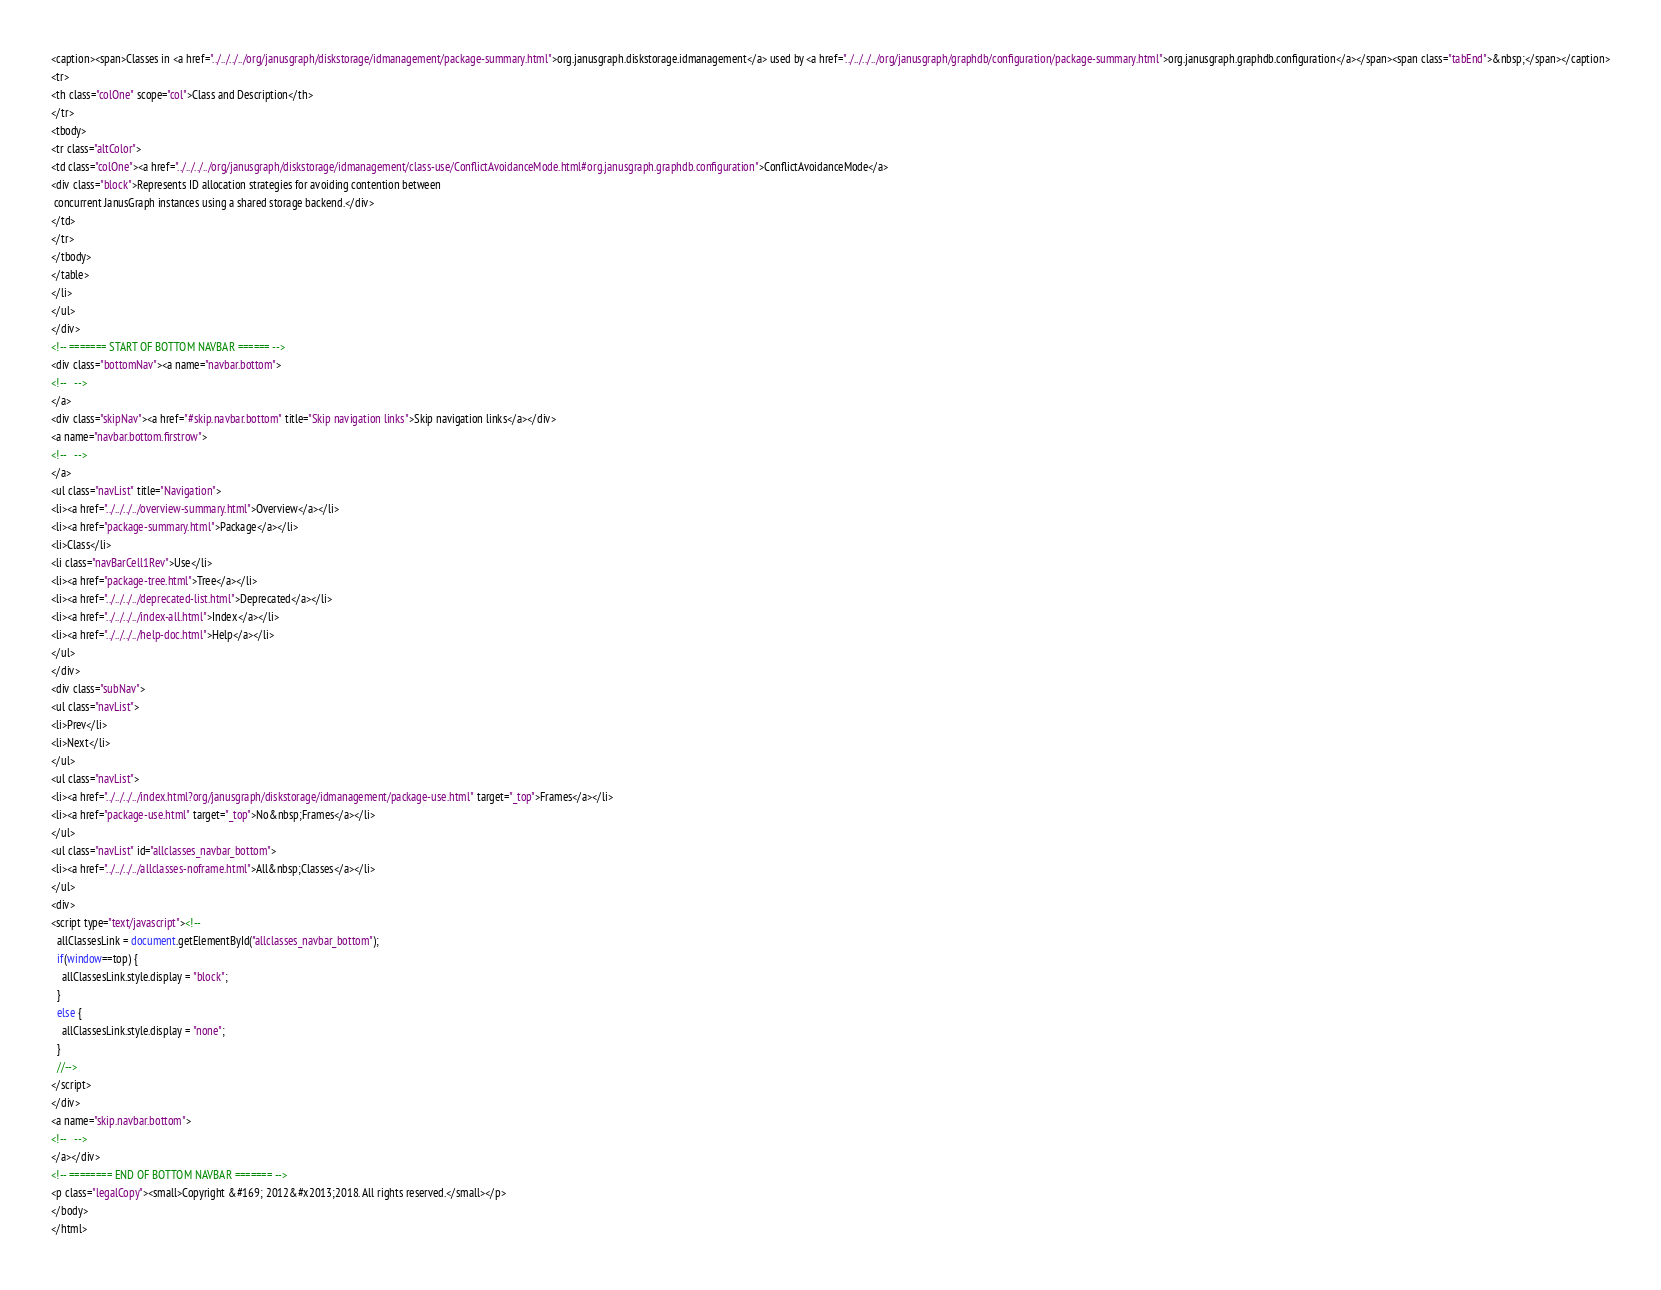<code> <loc_0><loc_0><loc_500><loc_500><_HTML_><caption><span>Classes in <a href="../../../../org/janusgraph/diskstorage/idmanagement/package-summary.html">org.janusgraph.diskstorage.idmanagement</a> used by <a href="../../../../org/janusgraph/graphdb/configuration/package-summary.html">org.janusgraph.graphdb.configuration</a></span><span class="tabEnd">&nbsp;</span></caption>
<tr>
<th class="colOne" scope="col">Class and Description</th>
</tr>
<tbody>
<tr class="altColor">
<td class="colOne"><a href="../../../../org/janusgraph/diskstorage/idmanagement/class-use/ConflictAvoidanceMode.html#org.janusgraph.graphdb.configuration">ConflictAvoidanceMode</a>
<div class="block">Represents ID allocation strategies for avoiding contention between
 concurrent JanusGraph instances using a shared storage backend.</div>
</td>
</tr>
</tbody>
</table>
</li>
</ul>
</div>
<!-- ======= START OF BOTTOM NAVBAR ====== -->
<div class="bottomNav"><a name="navbar.bottom">
<!--   -->
</a>
<div class="skipNav"><a href="#skip.navbar.bottom" title="Skip navigation links">Skip navigation links</a></div>
<a name="navbar.bottom.firstrow">
<!--   -->
</a>
<ul class="navList" title="Navigation">
<li><a href="../../../../overview-summary.html">Overview</a></li>
<li><a href="package-summary.html">Package</a></li>
<li>Class</li>
<li class="navBarCell1Rev">Use</li>
<li><a href="package-tree.html">Tree</a></li>
<li><a href="../../../../deprecated-list.html">Deprecated</a></li>
<li><a href="../../../../index-all.html">Index</a></li>
<li><a href="../../../../help-doc.html">Help</a></li>
</ul>
</div>
<div class="subNav">
<ul class="navList">
<li>Prev</li>
<li>Next</li>
</ul>
<ul class="navList">
<li><a href="../../../../index.html?org/janusgraph/diskstorage/idmanagement/package-use.html" target="_top">Frames</a></li>
<li><a href="package-use.html" target="_top">No&nbsp;Frames</a></li>
</ul>
<ul class="navList" id="allclasses_navbar_bottom">
<li><a href="../../../../allclasses-noframe.html">All&nbsp;Classes</a></li>
</ul>
<div>
<script type="text/javascript"><!--
  allClassesLink = document.getElementById("allclasses_navbar_bottom");
  if(window==top) {
    allClassesLink.style.display = "block";
  }
  else {
    allClassesLink.style.display = "none";
  }
  //-->
</script>
</div>
<a name="skip.navbar.bottom">
<!--   -->
</a></div>
<!-- ======== END OF BOTTOM NAVBAR ======= -->
<p class="legalCopy"><small>Copyright &#169; 2012&#x2013;2018. All rights reserved.</small></p>
</body>
</html>
</code> 